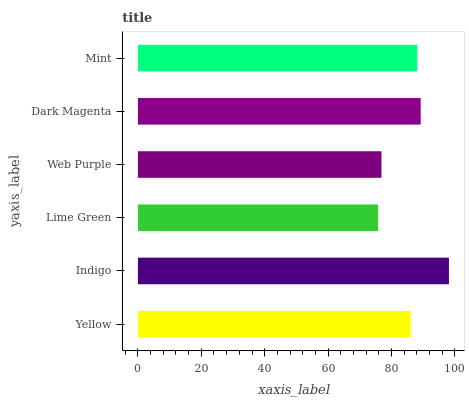Is Lime Green the minimum?
Answer yes or no. Yes. Is Indigo the maximum?
Answer yes or no. Yes. Is Indigo the minimum?
Answer yes or no. No. Is Lime Green the maximum?
Answer yes or no. No. Is Indigo greater than Lime Green?
Answer yes or no. Yes. Is Lime Green less than Indigo?
Answer yes or no. Yes. Is Lime Green greater than Indigo?
Answer yes or no. No. Is Indigo less than Lime Green?
Answer yes or no. No. Is Mint the high median?
Answer yes or no. Yes. Is Yellow the low median?
Answer yes or no. Yes. Is Web Purple the high median?
Answer yes or no. No. Is Dark Magenta the low median?
Answer yes or no. No. 